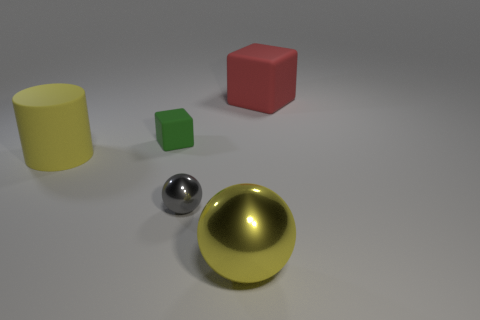Add 3 small shiny balls. How many objects exist? 8 Subtract all cylinders. How many objects are left? 4 Subtract 0 brown cubes. How many objects are left? 5 Subtract all tiny green rubber objects. Subtract all gray shiny objects. How many objects are left? 3 Add 2 large red things. How many large red things are left? 3 Add 1 matte blocks. How many matte blocks exist? 3 